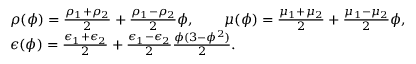Convert formula to latex. <formula><loc_0><loc_0><loc_500><loc_500>\begin{array} { r l } & { \rho ( \phi ) = \frac { \rho _ { 1 } + \rho _ { 2 } } { 2 } + \frac { \rho _ { 1 } - \rho _ { 2 } } { 2 } \phi , \quad \mu ( \phi ) = \frac { \mu _ { 1 } + \mu _ { 2 } } { 2 } + \frac { \mu _ { 1 } - \mu _ { 2 } } { 2 } \phi , } \\ & { \epsilon ( \phi ) = \frac { \epsilon _ { 1 } + \epsilon _ { 2 } } { 2 } + \frac { \epsilon _ { 1 } - \epsilon _ { 2 } } { 2 } \frac { \phi ( 3 - \phi ^ { 2 } ) } { 2 } . } \end{array}</formula> 